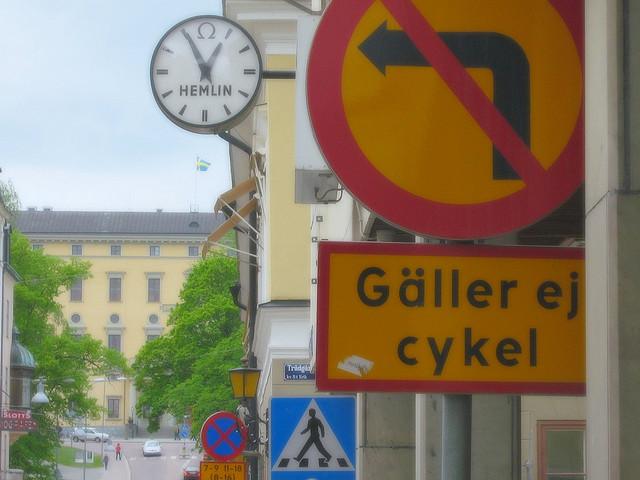How far must the driver go before being allowed to turn?
Give a very brief answer. 1 block. What time is it in the photo?
Be succinct. 12:55. Spell the last word on the bottom of the picture backwards?
Short answer required. Leaky. What does the sign say?
Keep it brief. Galler ej cykel. Who is the clockmaker?
Write a very short answer. Hemlin. What number is on the clock?
Write a very short answer. 12:55. What time is it?
Quick response, please. 12:55. What language appears on the signs?
Quick response, please. German. 